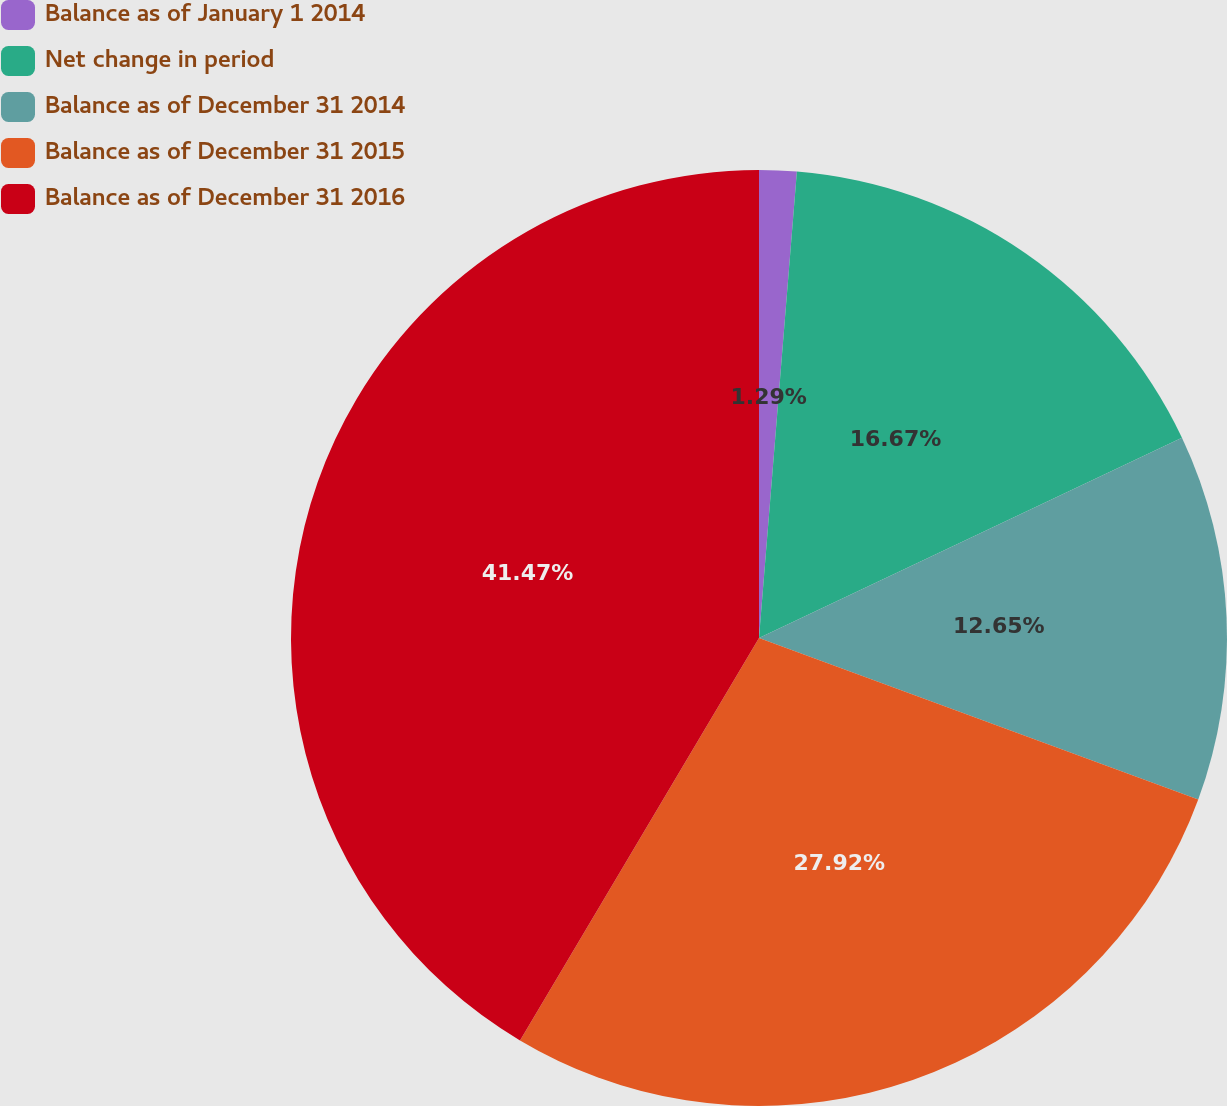Convert chart to OTSL. <chart><loc_0><loc_0><loc_500><loc_500><pie_chart><fcel>Balance as of January 1 2014<fcel>Net change in period<fcel>Balance as of December 31 2014<fcel>Balance as of December 31 2015<fcel>Balance as of December 31 2016<nl><fcel>1.29%<fcel>16.67%<fcel>12.65%<fcel>27.92%<fcel>41.47%<nl></chart> 